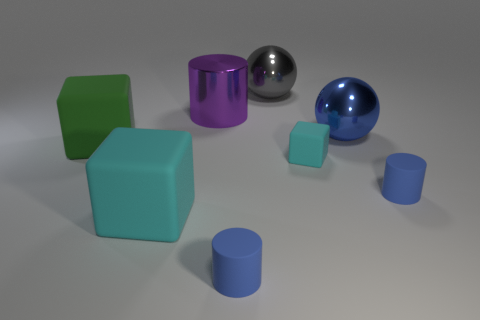Add 1 small matte objects. How many objects exist? 9 Subtract all spheres. How many objects are left? 6 Add 2 big blue balls. How many big blue balls exist? 3 Subtract 0 red blocks. How many objects are left? 8 Subtract all tiny yellow rubber cylinders. Subtract all small matte cylinders. How many objects are left? 6 Add 1 big blue metal spheres. How many big blue metal spheres are left? 2 